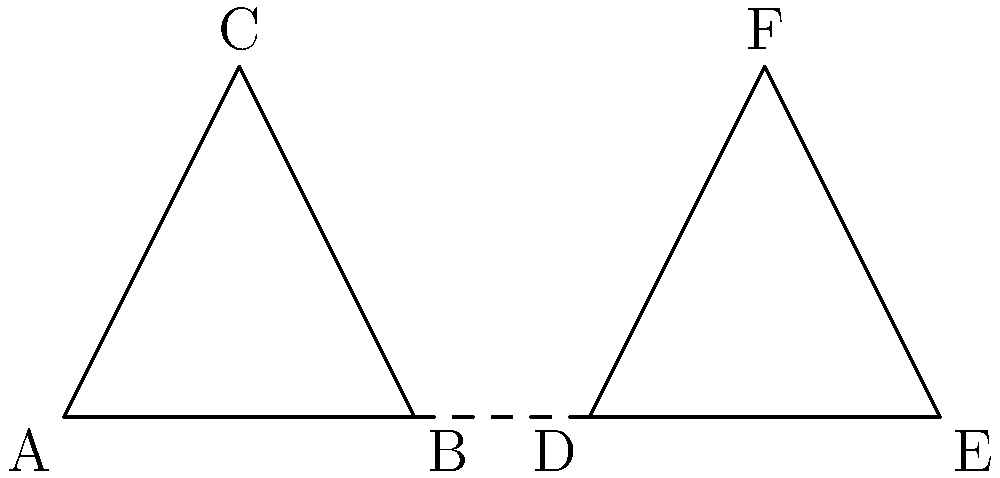In Korean calligraphy, two brush strokes form congruent triangles ABC and DEF. If AB = 2 cm and BC = 2.24 cm, what is the length of EF in centimeters? To solve this problem, let's follow these steps:

1. Recognize that triangles ABC and DEF are congruent. This means all corresponding sides and angles are equal.

2. We're given that AB = 2 cm and BC = 2.24 cm. In the congruent triangle DEF, DE corresponds to AB, and EF corresponds to BC.

3. Since the triangles are congruent, we can conclude:
   DE = AB = 2 cm
   EF = BC = 2.24 cm

4. Therefore, the length of EF is 2.24 cm.

This problem relates to Korean calligraphy by comparing brush strokes to geometric shapes, which is a common practice in analyzing the balance and proportion in East Asian calligraphy.
Answer: 2.24 cm 